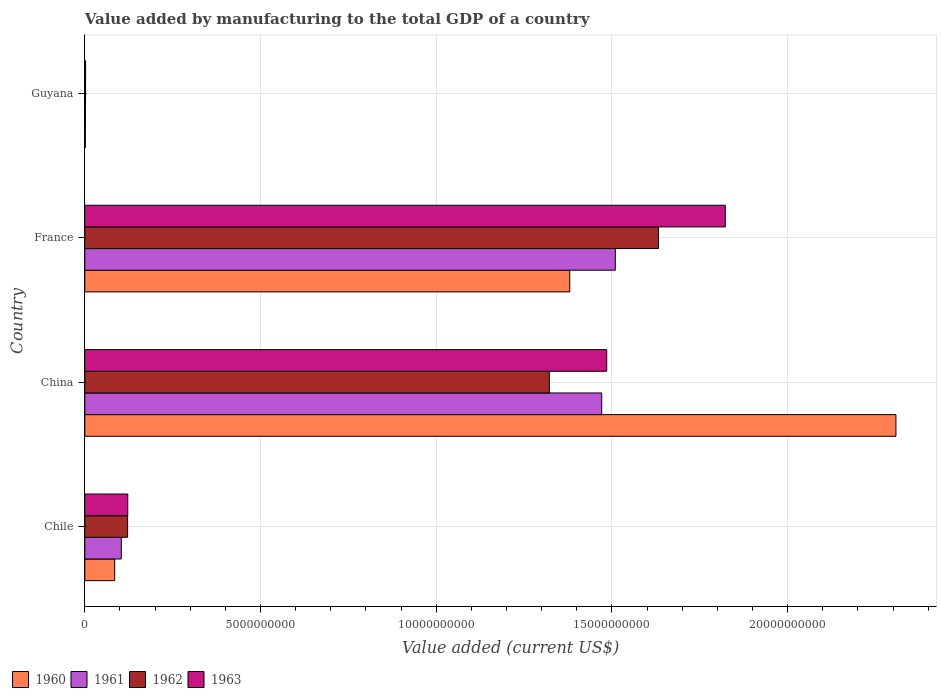How many groups of bars are there?
Keep it short and to the point. 4. Are the number of bars per tick equal to the number of legend labels?
Your answer should be very brief. Yes. Are the number of bars on each tick of the Y-axis equal?
Provide a succinct answer. Yes. How many bars are there on the 3rd tick from the top?
Offer a very short reply. 4. How many bars are there on the 3rd tick from the bottom?
Provide a succinct answer. 4. What is the label of the 1st group of bars from the top?
Provide a short and direct response. Guyana. What is the value added by manufacturing to the total GDP in 1963 in France?
Your answer should be very brief. 1.82e+1. Across all countries, what is the maximum value added by manufacturing to the total GDP in 1960?
Provide a short and direct response. 2.31e+1. Across all countries, what is the minimum value added by manufacturing to the total GDP in 1963?
Give a very brief answer. 2.32e+07. In which country was the value added by manufacturing to the total GDP in 1960 minimum?
Your answer should be very brief. Guyana. What is the total value added by manufacturing to the total GDP in 1963 in the graph?
Give a very brief answer. 3.43e+1. What is the difference between the value added by manufacturing to the total GDP in 1962 in China and that in Guyana?
Make the answer very short. 1.32e+1. What is the difference between the value added by manufacturing to the total GDP in 1960 in France and the value added by manufacturing to the total GDP in 1962 in China?
Offer a very short reply. 5.81e+08. What is the average value added by manufacturing to the total GDP in 1962 per country?
Offer a terse response. 7.70e+09. What is the difference between the value added by manufacturing to the total GDP in 1962 and value added by manufacturing to the total GDP in 1963 in Chile?
Your response must be concise. -4.28e+06. What is the ratio of the value added by manufacturing to the total GDP in 1961 in China to that in France?
Keep it short and to the point. 0.97. Is the difference between the value added by manufacturing to the total GDP in 1962 in China and Guyana greater than the difference between the value added by manufacturing to the total GDP in 1963 in China and Guyana?
Give a very brief answer. No. What is the difference between the highest and the second highest value added by manufacturing to the total GDP in 1962?
Your answer should be very brief. 3.11e+09. What is the difference between the highest and the lowest value added by manufacturing to the total GDP in 1960?
Offer a very short reply. 2.31e+1. In how many countries, is the value added by manufacturing to the total GDP in 1963 greater than the average value added by manufacturing to the total GDP in 1963 taken over all countries?
Your response must be concise. 2. Is the sum of the value added by manufacturing to the total GDP in 1963 in Chile and France greater than the maximum value added by manufacturing to the total GDP in 1961 across all countries?
Provide a short and direct response. Yes. Is it the case that in every country, the sum of the value added by manufacturing to the total GDP in 1961 and value added by manufacturing to the total GDP in 1962 is greater than the value added by manufacturing to the total GDP in 1960?
Provide a succinct answer. Yes. Are all the bars in the graph horizontal?
Offer a very short reply. Yes. What is the difference between two consecutive major ticks on the X-axis?
Keep it short and to the point. 5.00e+09. Are the values on the major ticks of X-axis written in scientific E-notation?
Keep it short and to the point. No. Where does the legend appear in the graph?
Make the answer very short. Bottom left. How are the legend labels stacked?
Ensure brevity in your answer.  Horizontal. What is the title of the graph?
Offer a very short reply. Value added by manufacturing to the total GDP of a country. What is the label or title of the X-axis?
Your response must be concise. Value added (current US$). What is the label or title of the Y-axis?
Your response must be concise. Country. What is the Value added (current US$) in 1960 in Chile?
Make the answer very short. 8.51e+08. What is the Value added (current US$) of 1961 in Chile?
Give a very brief answer. 1.04e+09. What is the Value added (current US$) in 1962 in Chile?
Give a very brief answer. 1.22e+09. What is the Value added (current US$) of 1963 in Chile?
Your answer should be compact. 1.22e+09. What is the Value added (current US$) of 1960 in China?
Offer a very short reply. 2.31e+1. What is the Value added (current US$) of 1961 in China?
Your response must be concise. 1.47e+1. What is the Value added (current US$) in 1962 in China?
Your answer should be compact. 1.32e+1. What is the Value added (current US$) in 1963 in China?
Provide a short and direct response. 1.49e+1. What is the Value added (current US$) in 1960 in France?
Offer a terse response. 1.38e+1. What is the Value added (current US$) of 1961 in France?
Make the answer very short. 1.51e+1. What is the Value added (current US$) in 1962 in France?
Keep it short and to the point. 1.63e+1. What is the Value added (current US$) of 1963 in France?
Ensure brevity in your answer.  1.82e+1. What is the Value added (current US$) of 1960 in Guyana?
Make the answer very short. 1.59e+07. What is the Value added (current US$) of 1961 in Guyana?
Provide a succinct answer. 1.84e+07. What is the Value added (current US$) in 1962 in Guyana?
Your answer should be compact. 2.08e+07. What is the Value added (current US$) of 1963 in Guyana?
Provide a succinct answer. 2.32e+07. Across all countries, what is the maximum Value added (current US$) of 1960?
Give a very brief answer. 2.31e+1. Across all countries, what is the maximum Value added (current US$) of 1961?
Your answer should be compact. 1.51e+1. Across all countries, what is the maximum Value added (current US$) in 1962?
Keep it short and to the point. 1.63e+1. Across all countries, what is the maximum Value added (current US$) of 1963?
Offer a very short reply. 1.82e+1. Across all countries, what is the minimum Value added (current US$) of 1960?
Your answer should be very brief. 1.59e+07. Across all countries, what is the minimum Value added (current US$) in 1961?
Keep it short and to the point. 1.84e+07. Across all countries, what is the minimum Value added (current US$) in 1962?
Ensure brevity in your answer.  2.08e+07. Across all countries, what is the minimum Value added (current US$) in 1963?
Your response must be concise. 2.32e+07. What is the total Value added (current US$) of 1960 in the graph?
Your answer should be compact. 3.77e+1. What is the total Value added (current US$) in 1961 in the graph?
Offer a very short reply. 3.09e+1. What is the total Value added (current US$) in 1962 in the graph?
Give a very brief answer. 3.08e+1. What is the total Value added (current US$) in 1963 in the graph?
Provide a succinct answer. 3.43e+1. What is the difference between the Value added (current US$) in 1960 in Chile and that in China?
Your answer should be compact. -2.22e+1. What is the difference between the Value added (current US$) of 1961 in Chile and that in China?
Make the answer very short. -1.37e+1. What is the difference between the Value added (current US$) of 1962 in Chile and that in China?
Your response must be concise. -1.20e+1. What is the difference between the Value added (current US$) in 1963 in Chile and that in China?
Give a very brief answer. -1.36e+1. What is the difference between the Value added (current US$) in 1960 in Chile and that in France?
Your answer should be very brief. -1.29e+1. What is the difference between the Value added (current US$) of 1961 in Chile and that in France?
Give a very brief answer. -1.41e+1. What is the difference between the Value added (current US$) of 1962 in Chile and that in France?
Your answer should be compact. -1.51e+1. What is the difference between the Value added (current US$) in 1963 in Chile and that in France?
Your response must be concise. -1.70e+1. What is the difference between the Value added (current US$) in 1960 in Chile and that in Guyana?
Offer a terse response. 8.35e+08. What is the difference between the Value added (current US$) of 1961 in Chile and that in Guyana?
Offer a very short reply. 1.02e+09. What is the difference between the Value added (current US$) of 1962 in Chile and that in Guyana?
Your response must be concise. 1.20e+09. What is the difference between the Value added (current US$) of 1963 in Chile and that in Guyana?
Make the answer very short. 1.20e+09. What is the difference between the Value added (current US$) in 1960 in China and that in France?
Offer a very short reply. 9.28e+09. What is the difference between the Value added (current US$) of 1961 in China and that in France?
Offer a terse response. -3.87e+08. What is the difference between the Value added (current US$) of 1962 in China and that in France?
Your answer should be very brief. -3.11e+09. What is the difference between the Value added (current US$) in 1963 in China and that in France?
Provide a succinct answer. -3.37e+09. What is the difference between the Value added (current US$) of 1960 in China and that in Guyana?
Make the answer very short. 2.31e+1. What is the difference between the Value added (current US$) of 1961 in China and that in Guyana?
Ensure brevity in your answer.  1.47e+1. What is the difference between the Value added (current US$) in 1962 in China and that in Guyana?
Give a very brief answer. 1.32e+1. What is the difference between the Value added (current US$) of 1963 in China and that in Guyana?
Offer a terse response. 1.48e+1. What is the difference between the Value added (current US$) of 1960 in France and that in Guyana?
Provide a short and direct response. 1.38e+1. What is the difference between the Value added (current US$) in 1961 in France and that in Guyana?
Give a very brief answer. 1.51e+1. What is the difference between the Value added (current US$) in 1962 in France and that in Guyana?
Give a very brief answer. 1.63e+1. What is the difference between the Value added (current US$) of 1963 in France and that in Guyana?
Make the answer very short. 1.82e+1. What is the difference between the Value added (current US$) in 1960 in Chile and the Value added (current US$) in 1961 in China?
Provide a short and direct response. -1.39e+1. What is the difference between the Value added (current US$) in 1960 in Chile and the Value added (current US$) in 1962 in China?
Make the answer very short. -1.24e+1. What is the difference between the Value added (current US$) of 1960 in Chile and the Value added (current US$) of 1963 in China?
Offer a terse response. -1.40e+1. What is the difference between the Value added (current US$) of 1961 in Chile and the Value added (current US$) of 1962 in China?
Give a very brief answer. -1.22e+1. What is the difference between the Value added (current US$) in 1961 in Chile and the Value added (current US$) in 1963 in China?
Your answer should be compact. -1.38e+1. What is the difference between the Value added (current US$) in 1962 in Chile and the Value added (current US$) in 1963 in China?
Provide a succinct answer. -1.36e+1. What is the difference between the Value added (current US$) of 1960 in Chile and the Value added (current US$) of 1961 in France?
Keep it short and to the point. -1.42e+1. What is the difference between the Value added (current US$) of 1960 in Chile and the Value added (current US$) of 1962 in France?
Keep it short and to the point. -1.55e+1. What is the difference between the Value added (current US$) of 1960 in Chile and the Value added (current US$) of 1963 in France?
Give a very brief answer. -1.74e+1. What is the difference between the Value added (current US$) of 1961 in Chile and the Value added (current US$) of 1962 in France?
Your response must be concise. -1.53e+1. What is the difference between the Value added (current US$) of 1961 in Chile and the Value added (current US$) of 1963 in France?
Make the answer very short. -1.72e+1. What is the difference between the Value added (current US$) in 1962 in Chile and the Value added (current US$) in 1963 in France?
Provide a succinct answer. -1.70e+1. What is the difference between the Value added (current US$) in 1960 in Chile and the Value added (current US$) in 1961 in Guyana?
Provide a succinct answer. 8.32e+08. What is the difference between the Value added (current US$) of 1960 in Chile and the Value added (current US$) of 1962 in Guyana?
Ensure brevity in your answer.  8.30e+08. What is the difference between the Value added (current US$) in 1960 in Chile and the Value added (current US$) in 1963 in Guyana?
Ensure brevity in your answer.  8.28e+08. What is the difference between the Value added (current US$) in 1961 in Chile and the Value added (current US$) in 1962 in Guyana?
Offer a very short reply. 1.02e+09. What is the difference between the Value added (current US$) in 1961 in Chile and the Value added (current US$) in 1963 in Guyana?
Give a very brief answer. 1.02e+09. What is the difference between the Value added (current US$) of 1962 in Chile and the Value added (current US$) of 1963 in Guyana?
Offer a terse response. 1.20e+09. What is the difference between the Value added (current US$) in 1960 in China and the Value added (current US$) in 1961 in France?
Ensure brevity in your answer.  7.98e+09. What is the difference between the Value added (current US$) of 1960 in China and the Value added (current US$) of 1962 in France?
Keep it short and to the point. 6.76e+09. What is the difference between the Value added (current US$) in 1960 in China and the Value added (current US$) in 1963 in France?
Your response must be concise. 4.86e+09. What is the difference between the Value added (current US$) of 1961 in China and the Value added (current US$) of 1962 in France?
Your response must be concise. -1.61e+09. What is the difference between the Value added (current US$) of 1961 in China and the Value added (current US$) of 1963 in France?
Make the answer very short. -3.52e+09. What is the difference between the Value added (current US$) of 1962 in China and the Value added (current US$) of 1963 in France?
Your response must be concise. -5.01e+09. What is the difference between the Value added (current US$) of 1960 in China and the Value added (current US$) of 1961 in Guyana?
Offer a terse response. 2.31e+1. What is the difference between the Value added (current US$) of 1960 in China and the Value added (current US$) of 1962 in Guyana?
Keep it short and to the point. 2.31e+1. What is the difference between the Value added (current US$) of 1960 in China and the Value added (current US$) of 1963 in Guyana?
Your answer should be compact. 2.31e+1. What is the difference between the Value added (current US$) of 1961 in China and the Value added (current US$) of 1962 in Guyana?
Ensure brevity in your answer.  1.47e+1. What is the difference between the Value added (current US$) in 1961 in China and the Value added (current US$) in 1963 in Guyana?
Offer a terse response. 1.47e+1. What is the difference between the Value added (current US$) in 1962 in China and the Value added (current US$) in 1963 in Guyana?
Make the answer very short. 1.32e+1. What is the difference between the Value added (current US$) of 1960 in France and the Value added (current US$) of 1961 in Guyana?
Your response must be concise. 1.38e+1. What is the difference between the Value added (current US$) in 1960 in France and the Value added (current US$) in 1962 in Guyana?
Give a very brief answer. 1.38e+1. What is the difference between the Value added (current US$) of 1960 in France and the Value added (current US$) of 1963 in Guyana?
Keep it short and to the point. 1.38e+1. What is the difference between the Value added (current US$) of 1961 in France and the Value added (current US$) of 1962 in Guyana?
Provide a succinct answer. 1.51e+1. What is the difference between the Value added (current US$) in 1961 in France and the Value added (current US$) in 1963 in Guyana?
Give a very brief answer. 1.51e+1. What is the difference between the Value added (current US$) in 1962 in France and the Value added (current US$) in 1963 in Guyana?
Provide a succinct answer. 1.63e+1. What is the average Value added (current US$) of 1960 per country?
Make the answer very short. 9.44e+09. What is the average Value added (current US$) in 1961 per country?
Offer a very short reply. 7.72e+09. What is the average Value added (current US$) of 1962 per country?
Your response must be concise. 7.70e+09. What is the average Value added (current US$) of 1963 per country?
Ensure brevity in your answer.  8.58e+09. What is the difference between the Value added (current US$) of 1960 and Value added (current US$) of 1961 in Chile?
Your answer should be very brief. -1.88e+08. What is the difference between the Value added (current US$) in 1960 and Value added (current US$) in 1962 in Chile?
Your answer should be very brief. -3.68e+08. What is the difference between the Value added (current US$) of 1960 and Value added (current US$) of 1963 in Chile?
Provide a short and direct response. -3.72e+08. What is the difference between the Value added (current US$) in 1961 and Value added (current US$) in 1962 in Chile?
Your response must be concise. -1.80e+08. What is the difference between the Value added (current US$) of 1961 and Value added (current US$) of 1963 in Chile?
Ensure brevity in your answer.  -1.84e+08. What is the difference between the Value added (current US$) in 1962 and Value added (current US$) in 1963 in Chile?
Keep it short and to the point. -4.28e+06. What is the difference between the Value added (current US$) in 1960 and Value added (current US$) in 1961 in China?
Provide a succinct answer. 8.37e+09. What is the difference between the Value added (current US$) in 1960 and Value added (current US$) in 1962 in China?
Provide a short and direct response. 9.86e+09. What is the difference between the Value added (current US$) of 1960 and Value added (current US$) of 1963 in China?
Ensure brevity in your answer.  8.23e+09. What is the difference between the Value added (current US$) of 1961 and Value added (current US$) of 1962 in China?
Provide a short and direct response. 1.49e+09. What is the difference between the Value added (current US$) of 1961 and Value added (current US$) of 1963 in China?
Provide a succinct answer. -1.42e+08. What is the difference between the Value added (current US$) of 1962 and Value added (current US$) of 1963 in China?
Your answer should be compact. -1.63e+09. What is the difference between the Value added (current US$) of 1960 and Value added (current US$) of 1961 in France?
Offer a terse response. -1.30e+09. What is the difference between the Value added (current US$) of 1960 and Value added (current US$) of 1962 in France?
Ensure brevity in your answer.  -2.52e+09. What is the difference between the Value added (current US$) of 1960 and Value added (current US$) of 1963 in France?
Your response must be concise. -4.43e+09. What is the difference between the Value added (current US$) of 1961 and Value added (current US$) of 1962 in France?
Provide a short and direct response. -1.23e+09. What is the difference between the Value added (current US$) of 1961 and Value added (current US$) of 1963 in France?
Offer a very short reply. -3.13e+09. What is the difference between the Value added (current US$) in 1962 and Value added (current US$) in 1963 in France?
Ensure brevity in your answer.  -1.90e+09. What is the difference between the Value added (current US$) in 1960 and Value added (current US$) in 1961 in Guyana?
Give a very brief answer. -2.51e+06. What is the difference between the Value added (current US$) of 1960 and Value added (current US$) of 1962 in Guyana?
Keep it short and to the point. -4.90e+06. What is the difference between the Value added (current US$) of 1960 and Value added (current US$) of 1963 in Guyana?
Offer a terse response. -7.29e+06. What is the difference between the Value added (current US$) in 1961 and Value added (current US$) in 1962 in Guyana?
Give a very brief answer. -2.39e+06. What is the difference between the Value added (current US$) of 1961 and Value added (current US$) of 1963 in Guyana?
Ensure brevity in your answer.  -4.78e+06. What is the difference between the Value added (current US$) of 1962 and Value added (current US$) of 1963 in Guyana?
Offer a terse response. -2.39e+06. What is the ratio of the Value added (current US$) in 1960 in Chile to that in China?
Offer a very short reply. 0.04. What is the ratio of the Value added (current US$) in 1961 in Chile to that in China?
Keep it short and to the point. 0.07. What is the ratio of the Value added (current US$) of 1962 in Chile to that in China?
Your response must be concise. 0.09. What is the ratio of the Value added (current US$) in 1963 in Chile to that in China?
Your answer should be compact. 0.08. What is the ratio of the Value added (current US$) in 1960 in Chile to that in France?
Your response must be concise. 0.06. What is the ratio of the Value added (current US$) in 1961 in Chile to that in France?
Your answer should be compact. 0.07. What is the ratio of the Value added (current US$) in 1962 in Chile to that in France?
Provide a short and direct response. 0.07. What is the ratio of the Value added (current US$) of 1963 in Chile to that in France?
Your response must be concise. 0.07. What is the ratio of the Value added (current US$) of 1960 in Chile to that in Guyana?
Keep it short and to the point. 53.62. What is the ratio of the Value added (current US$) in 1961 in Chile to that in Guyana?
Ensure brevity in your answer.  56.53. What is the ratio of the Value added (current US$) of 1962 in Chile to that in Guyana?
Offer a terse response. 58.67. What is the ratio of the Value added (current US$) in 1963 in Chile to that in Guyana?
Offer a very short reply. 52.79. What is the ratio of the Value added (current US$) of 1960 in China to that in France?
Keep it short and to the point. 1.67. What is the ratio of the Value added (current US$) in 1961 in China to that in France?
Offer a very short reply. 0.97. What is the ratio of the Value added (current US$) of 1962 in China to that in France?
Provide a succinct answer. 0.81. What is the ratio of the Value added (current US$) in 1963 in China to that in France?
Keep it short and to the point. 0.81. What is the ratio of the Value added (current US$) of 1960 in China to that in Guyana?
Your response must be concise. 1454.66. What is the ratio of the Value added (current US$) of 1961 in China to that in Guyana?
Your answer should be very brief. 800.48. What is the ratio of the Value added (current US$) in 1962 in China to that in Guyana?
Ensure brevity in your answer.  636.5. What is the ratio of the Value added (current US$) of 1963 in China to that in Guyana?
Offer a terse response. 641.28. What is the ratio of the Value added (current US$) of 1960 in France to that in Guyana?
Offer a very short reply. 869.7. What is the ratio of the Value added (current US$) in 1961 in France to that in Guyana?
Your answer should be very brief. 821.55. What is the ratio of the Value added (current US$) in 1962 in France to that in Guyana?
Provide a succinct answer. 786.05. What is the ratio of the Value added (current US$) of 1963 in France to that in Guyana?
Your answer should be compact. 786.97. What is the difference between the highest and the second highest Value added (current US$) of 1960?
Give a very brief answer. 9.28e+09. What is the difference between the highest and the second highest Value added (current US$) in 1961?
Your answer should be very brief. 3.87e+08. What is the difference between the highest and the second highest Value added (current US$) in 1962?
Give a very brief answer. 3.11e+09. What is the difference between the highest and the second highest Value added (current US$) of 1963?
Provide a succinct answer. 3.37e+09. What is the difference between the highest and the lowest Value added (current US$) in 1960?
Keep it short and to the point. 2.31e+1. What is the difference between the highest and the lowest Value added (current US$) in 1961?
Offer a terse response. 1.51e+1. What is the difference between the highest and the lowest Value added (current US$) in 1962?
Your answer should be compact. 1.63e+1. What is the difference between the highest and the lowest Value added (current US$) in 1963?
Your answer should be very brief. 1.82e+1. 